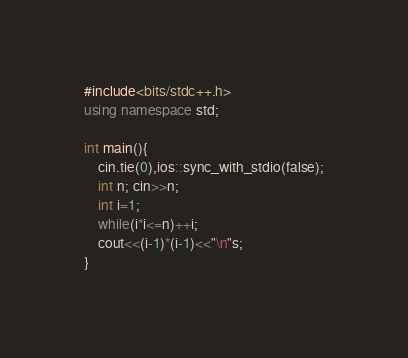<code> <loc_0><loc_0><loc_500><loc_500><_C++_>#include<bits/stdc++.h>
using namespace std;

int main(){
	cin.tie(0),ios::sync_with_stdio(false);
	int n; cin>>n;
	int i=1;
	while(i*i<=n)++i;
	cout<<(i-1)*(i-1)<<"\n"s;
}</code> 